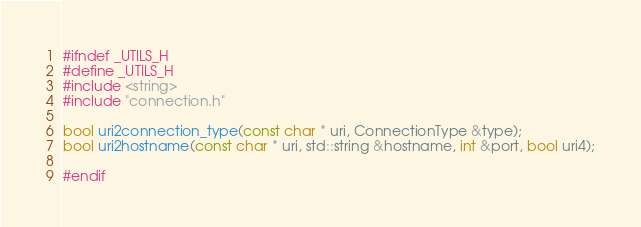Convert code to text. <code><loc_0><loc_0><loc_500><loc_500><_C_>#ifndef _UTILS_H
#define _UTILS_H
#include <string>
#include "connection.h"

bool uri2connection_type(const char * uri, ConnectionType &type);
bool uri2hostname(const char * uri, std::string &hostname, int &port, bool uri4);

#endif
</code> 